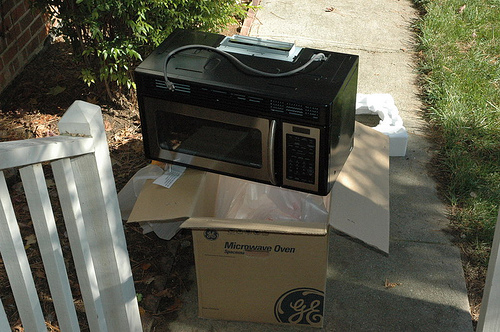Read and extract the text from this image. Microwave Oven GE 